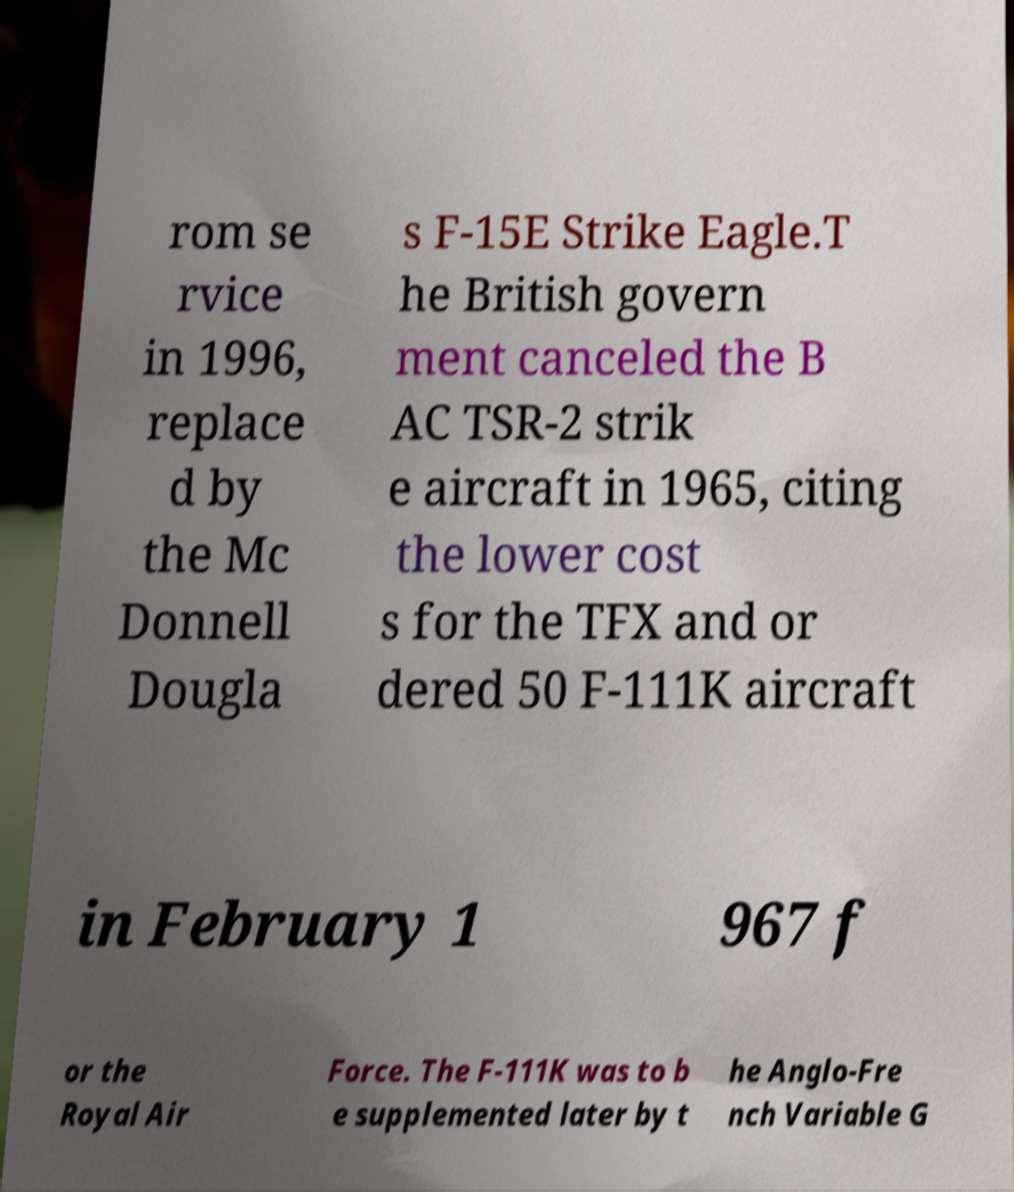For documentation purposes, I need the text within this image transcribed. Could you provide that? rom se rvice in 1996, replace d by the Mc Donnell Dougla s F-15E Strike Eagle.T he British govern ment canceled the B AC TSR-2 strik e aircraft in 1965, citing the lower cost s for the TFX and or dered 50 F-111K aircraft in February 1 967 f or the Royal Air Force. The F-111K was to b e supplemented later by t he Anglo-Fre nch Variable G 